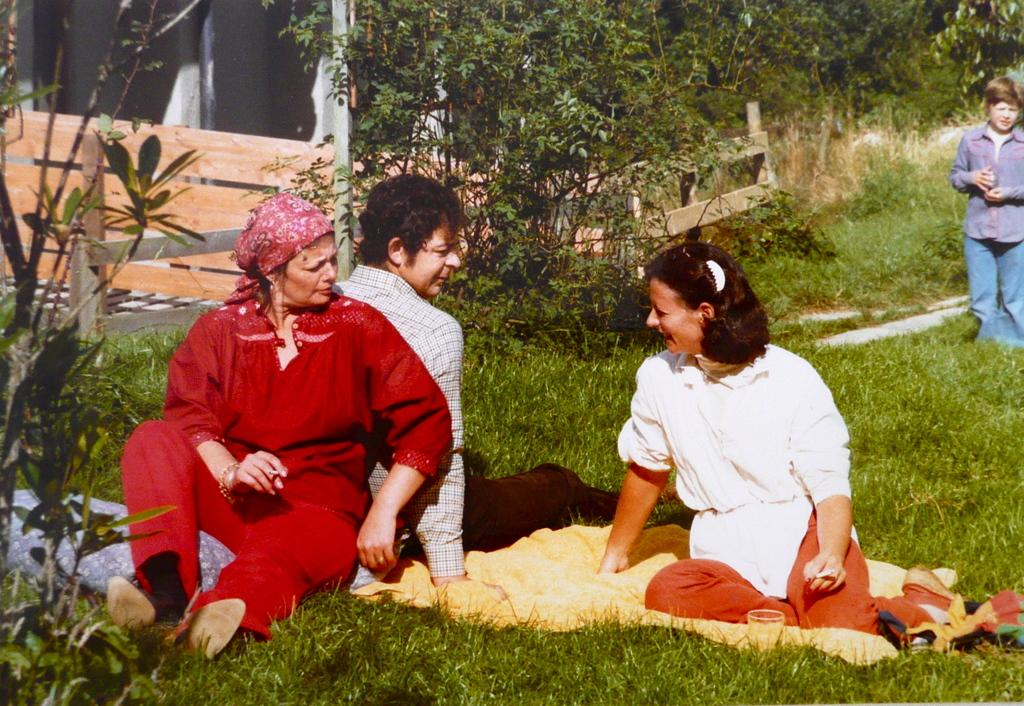What is the primary vegetation covering the land in the image? The land is covered with grass. How many people are sitting in the image? There are three people sitting in the image. What is the boy in the image doing? A boy is standing far from the sitting people. What can be seen in the background of the image? There is a fence and plants in the background of the image. What type of harmony is being played by the cows in the image? There are no cows present in the image, so it is not possible to determine if any harmony is being played. 